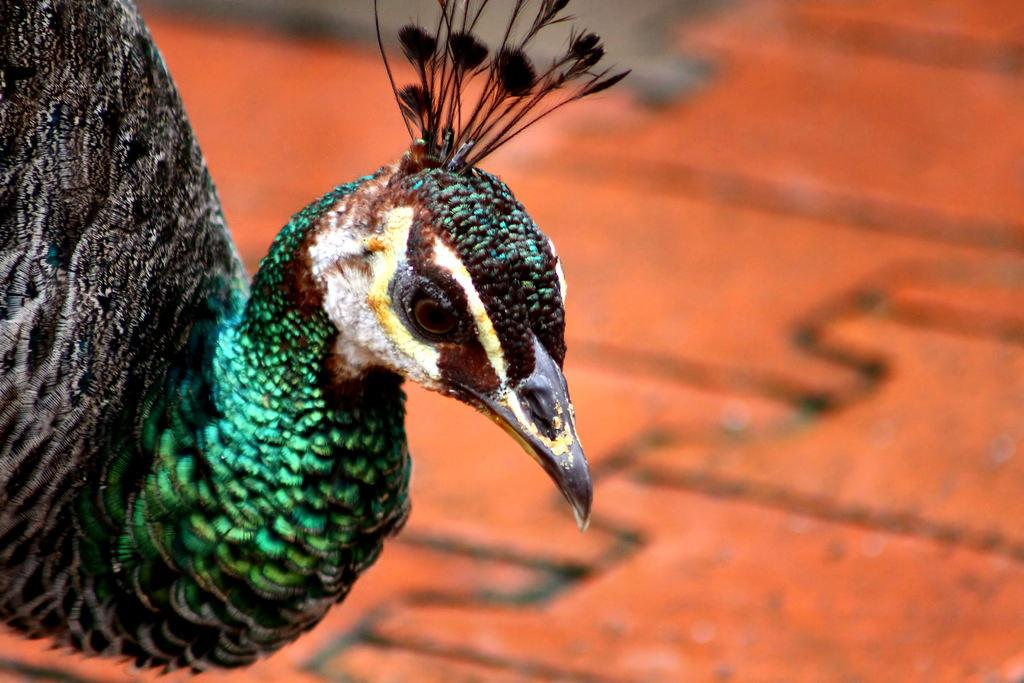What type of animal is the main subject of the image? There is a peacock in the image. Can you describe the background of the image? The background of the image is blurred. What type of slope can be seen in the image? There is no slope present in the image; it features a peacock with a blurred background. Can you tell me how many plates are visible in the image? There are no plates present in the image. What type of snake is visible in the image? There is no snake present in the image. 